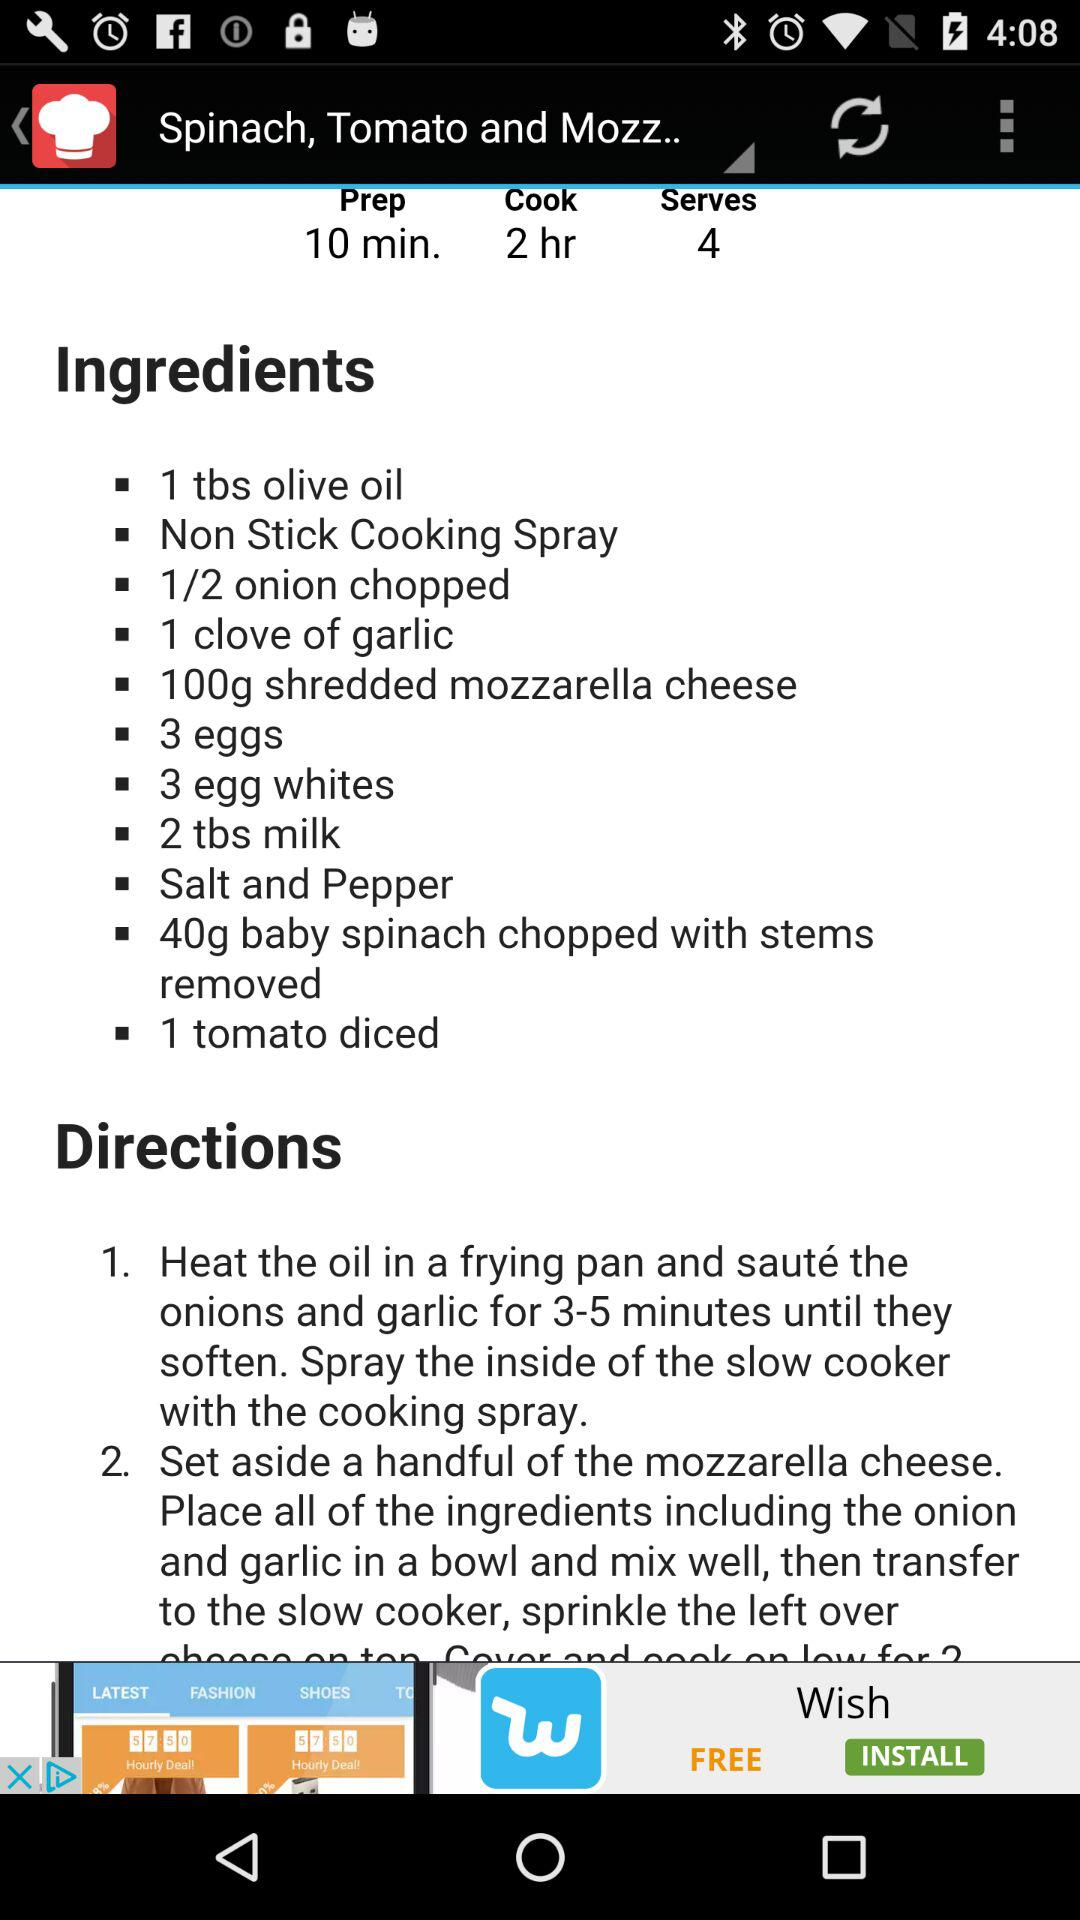How much mozzarella cheese will be used in the dish? In the dish, 100 grams of shredded mozzarella cheese will be used. 